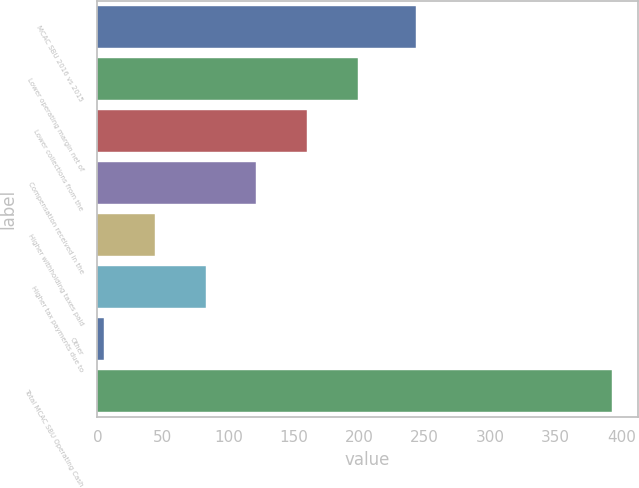<chart> <loc_0><loc_0><loc_500><loc_500><bar_chart><fcel>MCAC SBU 2016 vs 2015<fcel>Lower operating margin net of<fcel>Lower collections from the<fcel>Compensation received in the<fcel>Higher withholding taxes paid<fcel>Higher tax payments due to<fcel>Other<fcel>Total MCAC SBU Operating Cash<nl><fcel>243<fcel>199<fcel>160.2<fcel>121.4<fcel>43.8<fcel>82.6<fcel>5<fcel>393<nl></chart> 